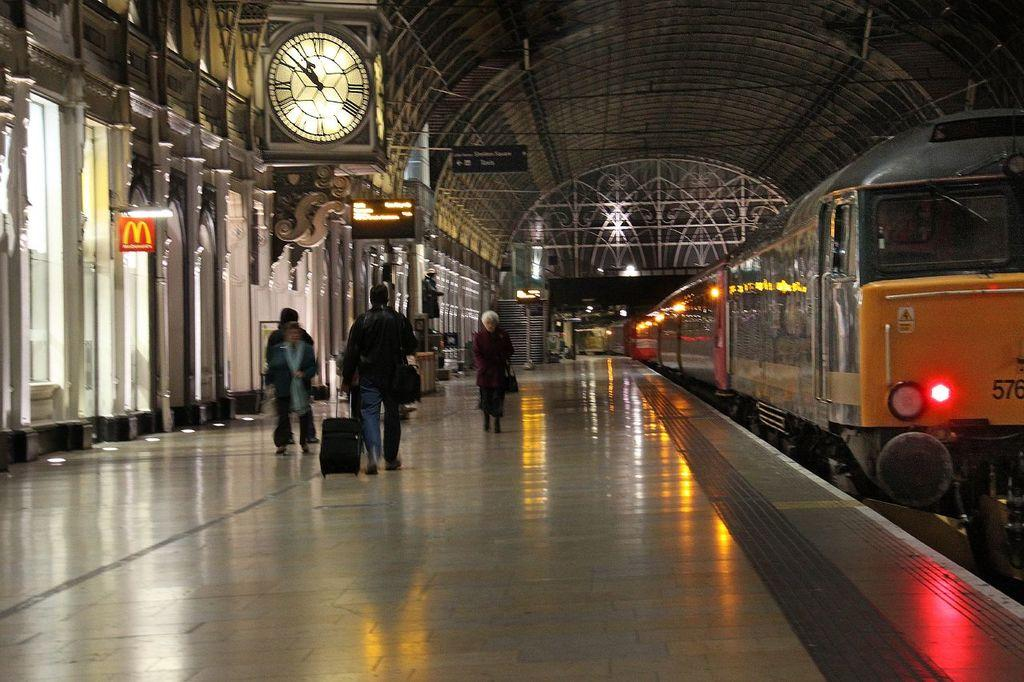What type of location is depicted in the image? The image shows a railway station. What can be seen at the top of the image? There is a clock at the top of the image. What is located on the right side of the image? There is a train on the right side of the image. What type of crime is being committed in the image? There is no crime being committed in the image; it shows a railway station with a clock and a train. Can you see any ants in the image? There are no ants present in the image. 